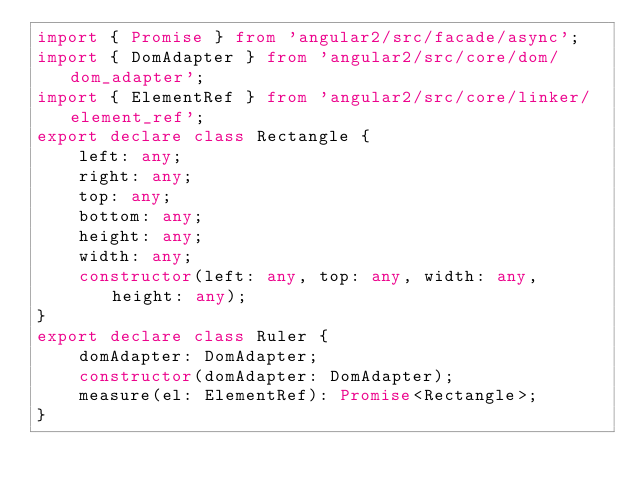<code> <loc_0><loc_0><loc_500><loc_500><_TypeScript_>import { Promise } from 'angular2/src/facade/async';
import { DomAdapter } from 'angular2/src/core/dom/dom_adapter';
import { ElementRef } from 'angular2/src/core/linker/element_ref';
export declare class Rectangle {
    left: any;
    right: any;
    top: any;
    bottom: any;
    height: any;
    width: any;
    constructor(left: any, top: any, width: any, height: any);
}
export declare class Ruler {
    domAdapter: DomAdapter;
    constructor(domAdapter: DomAdapter);
    measure(el: ElementRef): Promise<Rectangle>;
}
</code> 